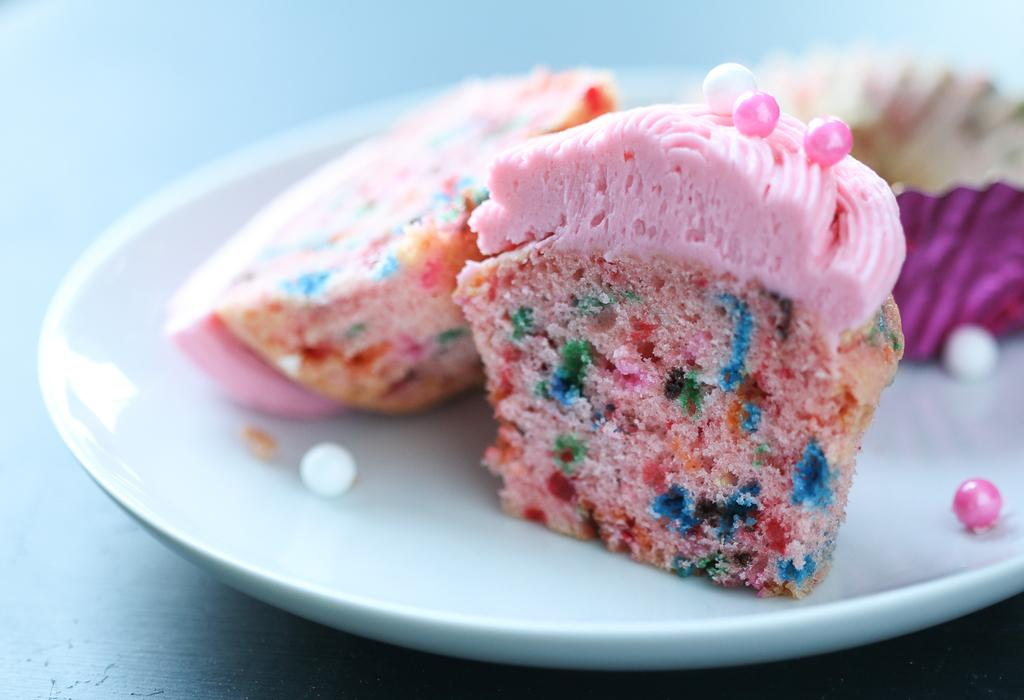What type of food is present on the plate in the image? There are pieces of cake in a plate in the image. Can you describe the setting where the plate is located? The image is taken in a room. What scent can be detected in the room from the image? There is no information about the scent in the room provided in the image. 